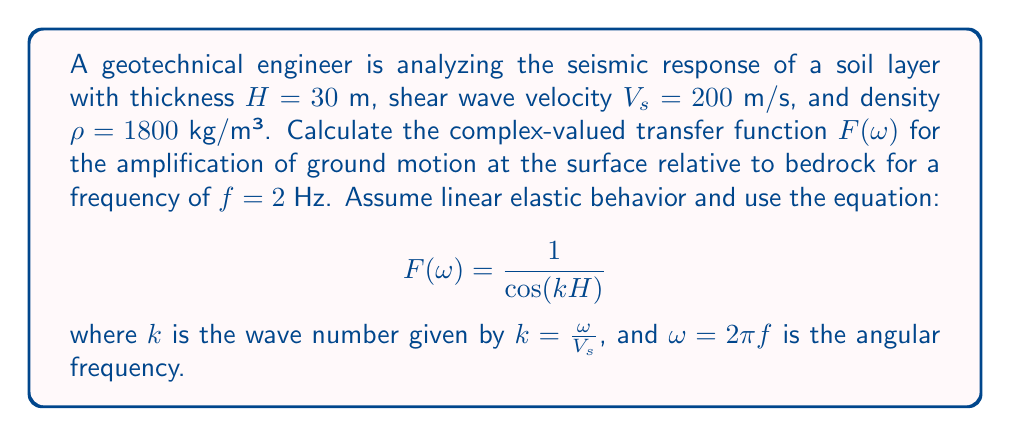Give your solution to this math problem. To solve this problem, we'll follow these steps:

1) Calculate the angular frequency $\omega$:
   $$\omega = 2\pi f = 2\pi \cdot 2 = 4\pi \text{ rad/s}$$

2) Calculate the wave number $k$:
   $$k = \frac{\omega}{V_s} = \frac{4\pi}{200} = \frac{\pi}{50} \text{ m}^{-1}$$

3) Calculate $kH$:
   $$kH = \frac{\pi}{50} \cdot 30 = \frac{3\pi}{5} \text{ rad}$$

4) Calculate $\cos(kH)$:
   $$\cos(kH) = \cos(\frac{3\pi}{5}) \approx -0.309$$

5) Calculate the transfer function $F(\omega)$:
   $$F(\omega) = \frac{1}{\cos(kH)} = \frac{1}{-0.309} \approx -3.236$$

The complex-valued transfer function is a real number in this case because we assumed linear elastic behavior without damping. In reality, soil behavior is more complex and would introduce imaginary components to account for phase shifts and energy dissipation.
Answer: $F(\omega) \approx -3.236$ 